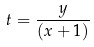Convert formula to latex. <formula><loc_0><loc_0><loc_500><loc_500>t = \frac { y } { ( x + 1 ) }</formula> 